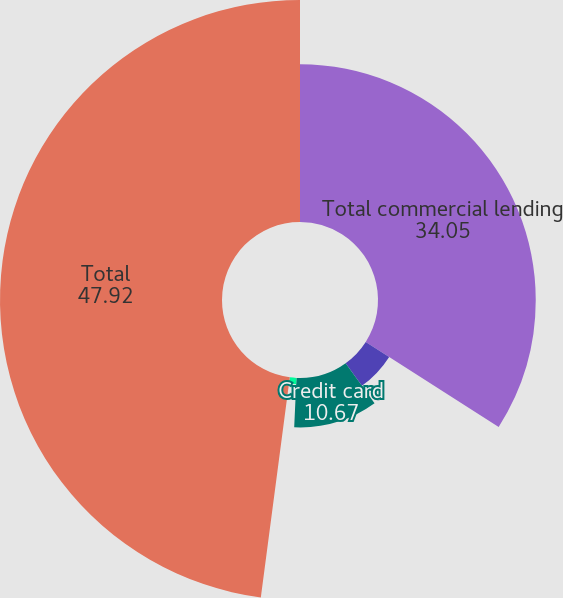Convert chart to OTSL. <chart><loc_0><loc_0><loc_500><loc_500><pie_chart><fcel>Total commercial lending<fcel>Home equity lines of credit<fcel>Credit card<fcel>Other<fcel>Total<nl><fcel>34.05%<fcel>6.01%<fcel>10.67%<fcel>1.36%<fcel>47.92%<nl></chart> 